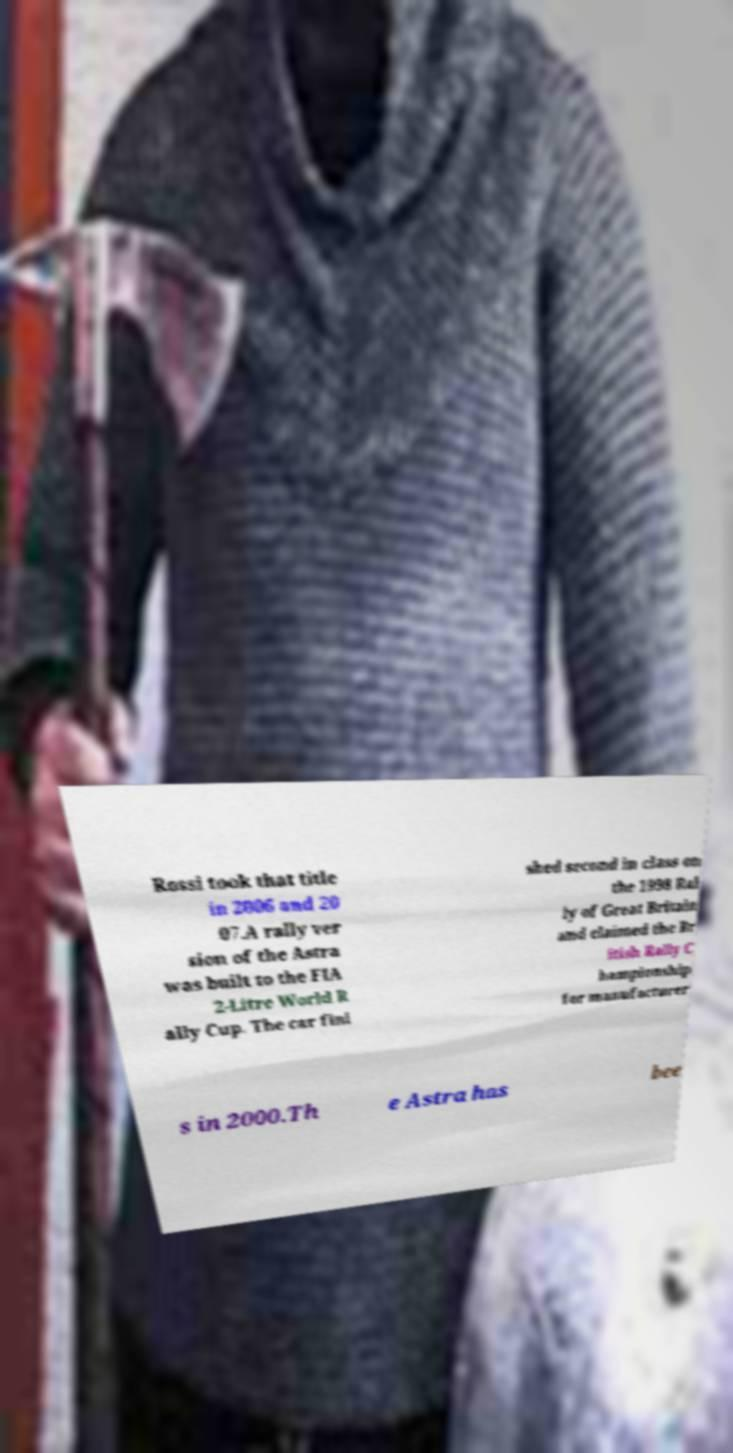Please identify and transcribe the text found in this image. Rossi took that title in 2006 and 20 07.A rally ver sion of the Astra was built to the FIA 2-Litre World R ally Cup. The car fini shed second in class on the 1998 Ral ly of Great Britain and claimed the Br itish Rally C hampionship for manufacturer s in 2000.Th e Astra has bee 